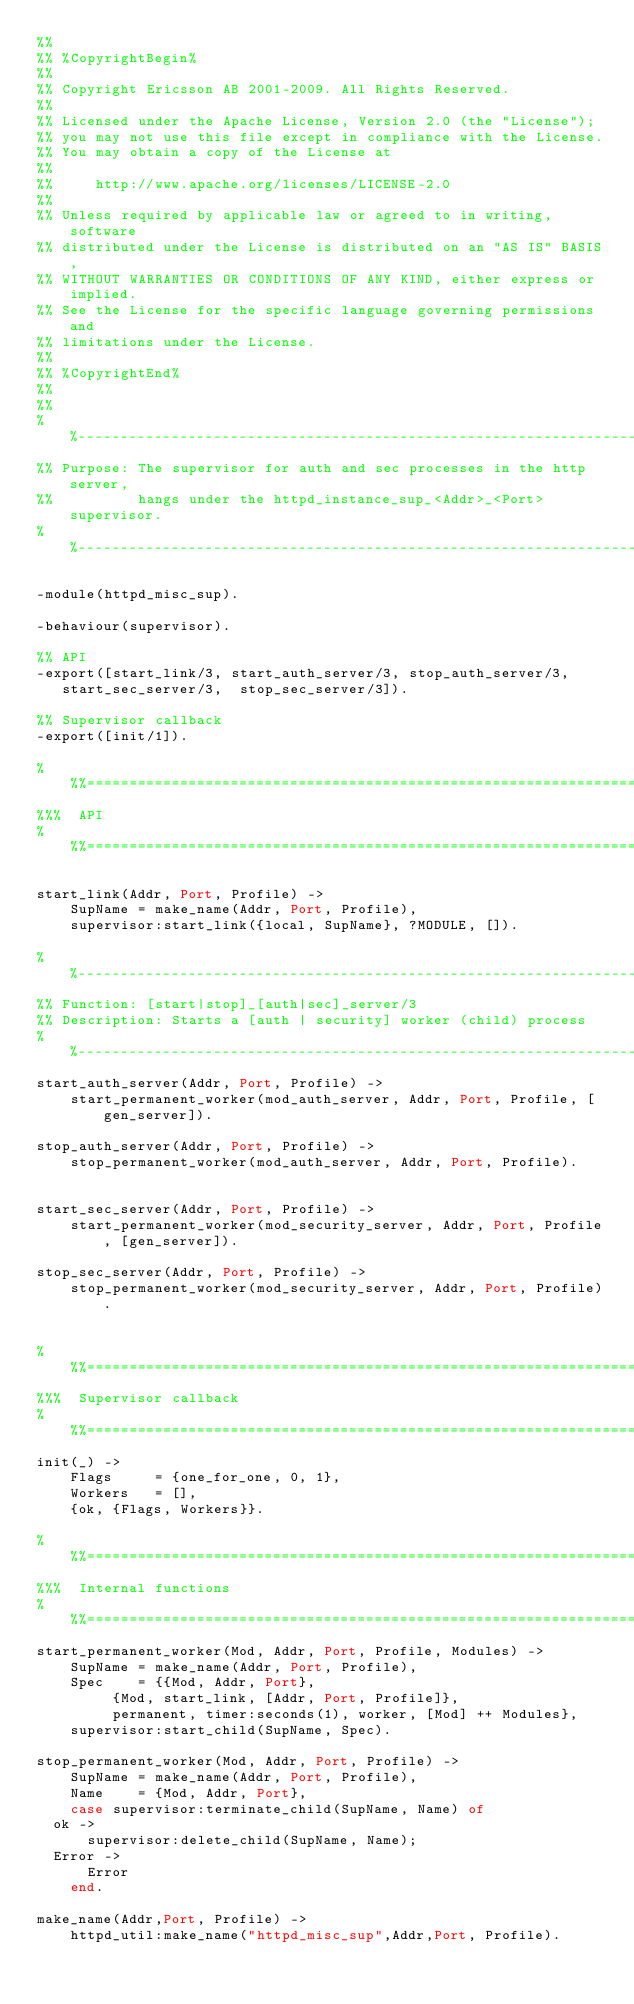<code> <loc_0><loc_0><loc_500><loc_500><_Erlang_>%%
%% %CopyrightBegin%
%% 
%% Copyright Ericsson AB 2001-2009. All Rights Reserved.
%% 
%% Licensed under the Apache License, Version 2.0 (the "License");
%% you may not use this file except in compliance with the License.
%% You may obtain a copy of the License at
%%
%%     http://www.apache.org/licenses/LICENSE-2.0
%%
%% Unless required by applicable law or agreed to in writing, software
%% distributed under the License is distributed on an "AS IS" BASIS,
%% WITHOUT WARRANTIES OR CONDITIONS OF ANY KIND, either express or implied.
%% See the License for the specific language governing permissions and
%% limitations under the License.
%% 
%% %CopyrightEnd%
%%
%%
%%----------------------------------------------------------------------
%% Purpose: The supervisor for auth and sec processes in the http server, 
%%          hangs under the httpd_instance_sup_<Addr>_<Port> supervisor.
%%----------------------------------------------------------------------

-module(httpd_misc_sup).

-behaviour(supervisor).

%% API 
-export([start_link/3, start_auth_server/3, stop_auth_server/3, 
	 start_sec_server/3,  stop_sec_server/3]).

%% Supervisor callback
-export([init/1]).

%%%=========================================================================
%%%  API
%%%=========================================================================

start_link(Addr, Port, Profile) ->
    SupName = make_name(Addr, Port, Profile),
    supervisor:start_link({local, SupName}, ?MODULE, []).

%%----------------------------------------------------------------------
%% Function: [start|stop]_[auth|sec]_server/3
%% Description: Starts a [auth | security] worker (child) process
%%----------------------------------------------------------------------
start_auth_server(Addr, Port, Profile) ->
    start_permanent_worker(mod_auth_server, Addr, Port, Profile, [gen_server]).

stop_auth_server(Addr, Port, Profile) ->
    stop_permanent_worker(mod_auth_server, Addr, Port, Profile).


start_sec_server(Addr, Port, Profile) ->
    start_permanent_worker(mod_security_server, Addr, Port, Profile, [gen_server]).

stop_sec_server(Addr, Port, Profile) ->
    stop_permanent_worker(mod_security_server, Addr, Port, Profile).


%%%=========================================================================
%%%  Supervisor callback
%%%=========================================================================
init(_) -> 
    Flags     = {one_for_one, 0, 1},
    Workers   = [],
    {ok, {Flags, Workers}}.

%%%=========================================================================
%%%  Internal functions
%%%=========================================================================
start_permanent_worker(Mod, Addr, Port, Profile, Modules) ->
    SupName = make_name(Addr, Port, Profile),
    Spec    = {{Mod, Addr, Port},
	       {Mod, start_link, [Addr, Port, Profile]}, 
	       permanent, timer:seconds(1), worker, [Mod] ++ Modules},
    supervisor:start_child(SupName, Spec).

stop_permanent_worker(Mod, Addr, Port, Profile) ->
    SupName = make_name(Addr, Port, Profile),
    Name    = {Mod, Addr, Port},
    case supervisor:terminate_child(SupName, Name) of
	ok ->
	    supervisor:delete_child(SupName, Name);
	Error ->
	    Error
    end.
    
make_name(Addr,Port, Profile) ->
    httpd_util:make_name("httpd_misc_sup",Addr,Port, Profile).
</code> 